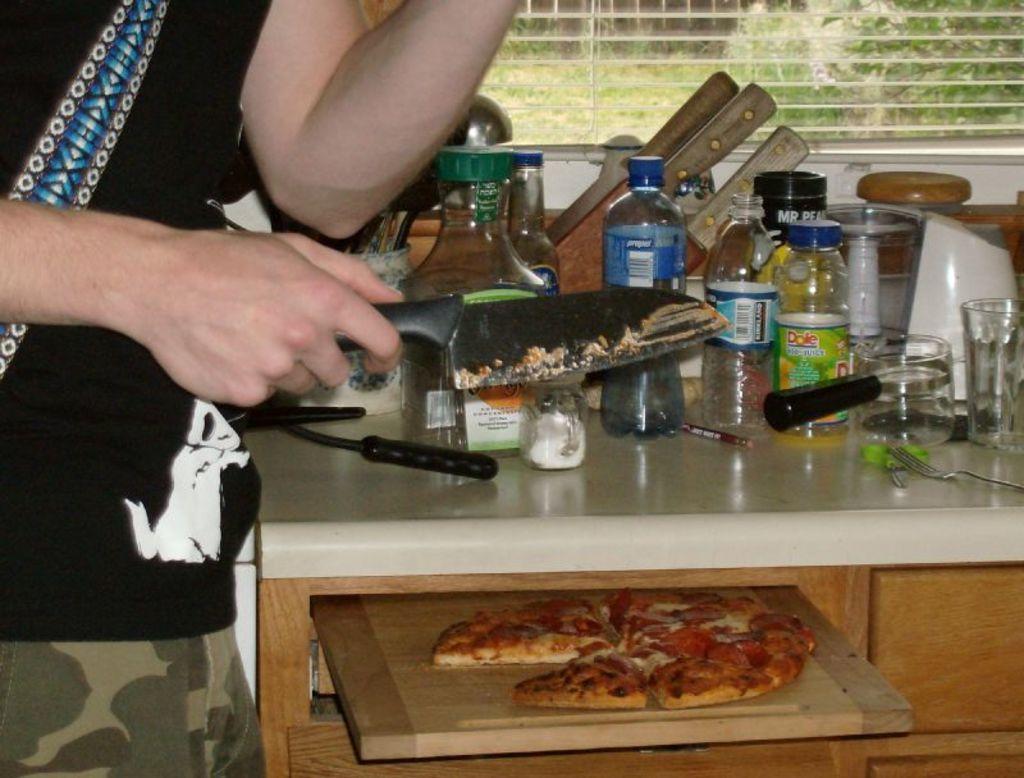Can you describe this image briefly? Here we can see a person holding a knife in his hand and there are various jars present on the table and below the table we can see a pizza present 